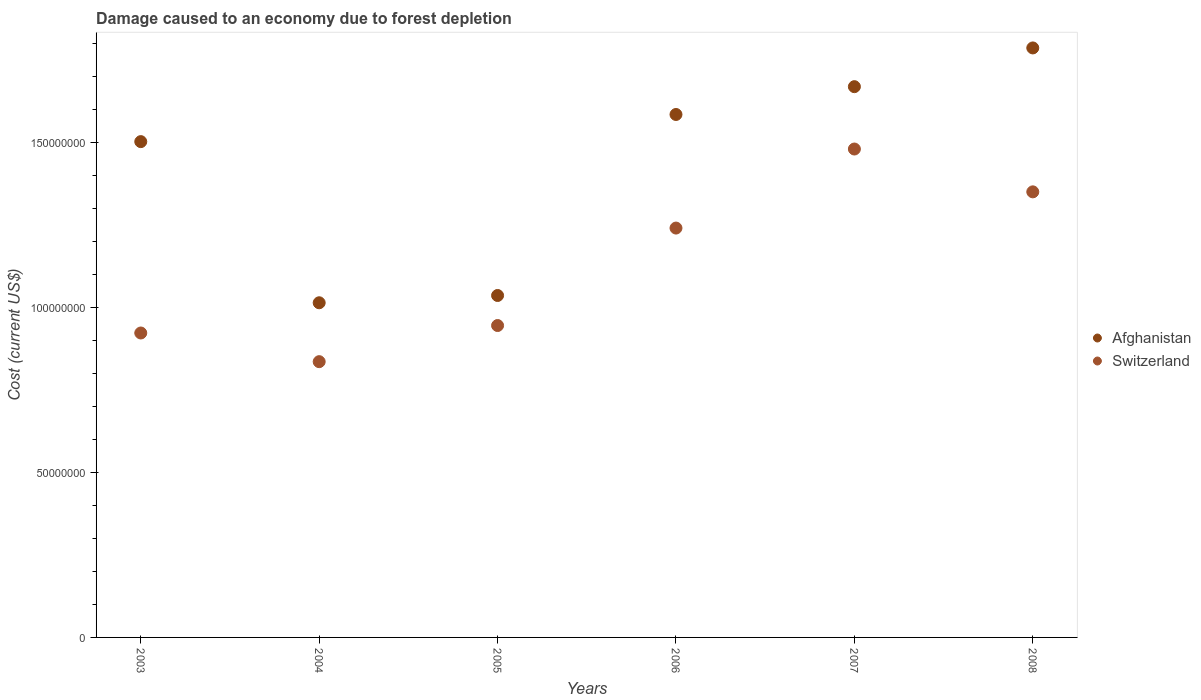Is the number of dotlines equal to the number of legend labels?
Your answer should be very brief. Yes. What is the cost of damage caused due to forest depletion in Afghanistan in 2005?
Your answer should be very brief. 1.04e+08. Across all years, what is the maximum cost of damage caused due to forest depletion in Switzerland?
Offer a very short reply. 1.48e+08. Across all years, what is the minimum cost of damage caused due to forest depletion in Afghanistan?
Your answer should be very brief. 1.01e+08. In which year was the cost of damage caused due to forest depletion in Afghanistan maximum?
Give a very brief answer. 2008. What is the total cost of damage caused due to forest depletion in Afghanistan in the graph?
Offer a very short reply. 8.59e+08. What is the difference between the cost of damage caused due to forest depletion in Switzerland in 2004 and that in 2005?
Provide a succinct answer. -1.09e+07. What is the difference between the cost of damage caused due to forest depletion in Switzerland in 2005 and the cost of damage caused due to forest depletion in Afghanistan in 2008?
Provide a short and direct response. -8.41e+07. What is the average cost of damage caused due to forest depletion in Afghanistan per year?
Provide a short and direct response. 1.43e+08. In the year 2006, what is the difference between the cost of damage caused due to forest depletion in Afghanistan and cost of damage caused due to forest depletion in Switzerland?
Offer a very short reply. 3.44e+07. In how many years, is the cost of damage caused due to forest depletion in Switzerland greater than 10000000 US$?
Offer a terse response. 6. What is the ratio of the cost of damage caused due to forest depletion in Afghanistan in 2006 to that in 2007?
Make the answer very short. 0.95. What is the difference between the highest and the second highest cost of damage caused due to forest depletion in Afghanistan?
Offer a very short reply. 1.17e+07. What is the difference between the highest and the lowest cost of damage caused due to forest depletion in Afghanistan?
Your response must be concise. 7.72e+07. Is the sum of the cost of damage caused due to forest depletion in Afghanistan in 2003 and 2006 greater than the maximum cost of damage caused due to forest depletion in Switzerland across all years?
Your answer should be very brief. Yes. Does the cost of damage caused due to forest depletion in Afghanistan monotonically increase over the years?
Your answer should be very brief. No. Is the cost of damage caused due to forest depletion in Afghanistan strictly greater than the cost of damage caused due to forest depletion in Switzerland over the years?
Offer a terse response. Yes. How many years are there in the graph?
Give a very brief answer. 6. What is the difference between two consecutive major ticks on the Y-axis?
Offer a terse response. 5.00e+07. Are the values on the major ticks of Y-axis written in scientific E-notation?
Your answer should be very brief. No. Does the graph contain grids?
Offer a very short reply. No. How are the legend labels stacked?
Keep it short and to the point. Vertical. What is the title of the graph?
Offer a very short reply. Damage caused to an economy due to forest depletion. What is the label or title of the Y-axis?
Provide a succinct answer. Cost (current US$). What is the Cost (current US$) in Afghanistan in 2003?
Offer a terse response. 1.50e+08. What is the Cost (current US$) of Switzerland in 2003?
Provide a succinct answer. 9.22e+07. What is the Cost (current US$) of Afghanistan in 2004?
Provide a succinct answer. 1.01e+08. What is the Cost (current US$) of Switzerland in 2004?
Your answer should be very brief. 8.35e+07. What is the Cost (current US$) in Afghanistan in 2005?
Your answer should be compact. 1.04e+08. What is the Cost (current US$) in Switzerland in 2005?
Keep it short and to the point. 9.45e+07. What is the Cost (current US$) in Afghanistan in 2006?
Give a very brief answer. 1.58e+08. What is the Cost (current US$) of Switzerland in 2006?
Offer a very short reply. 1.24e+08. What is the Cost (current US$) in Afghanistan in 2007?
Make the answer very short. 1.67e+08. What is the Cost (current US$) of Switzerland in 2007?
Offer a terse response. 1.48e+08. What is the Cost (current US$) of Afghanistan in 2008?
Your answer should be very brief. 1.79e+08. What is the Cost (current US$) in Switzerland in 2008?
Keep it short and to the point. 1.35e+08. Across all years, what is the maximum Cost (current US$) of Afghanistan?
Offer a terse response. 1.79e+08. Across all years, what is the maximum Cost (current US$) of Switzerland?
Your response must be concise. 1.48e+08. Across all years, what is the minimum Cost (current US$) in Afghanistan?
Provide a short and direct response. 1.01e+08. Across all years, what is the minimum Cost (current US$) in Switzerland?
Make the answer very short. 8.35e+07. What is the total Cost (current US$) of Afghanistan in the graph?
Your answer should be compact. 8.59e+08. What is the total Cost (current US$) in Switzerland in the graph?
Make the answer very short. 6.77e+08. What is the difference between the Cost (current US$) of Afghanistan in 2003 and that in 2004?
Your response must be concise. 4.88e+07. What is the difference between the Cost (current US$) of Switzerland in 2003 and that in 2004?
Offer a terse response. 8.68e+06. What is the difference between the Cost (current US$) in Afghanistan in 2003 and that in 2005?
Offer a very short reply. 4.66e+07. What is the difference between the Cost (current US$) of Switzerland in 2003 and that in 2005?
Make the answer very short. -2.26e+06. What is the difference between the Cost (current US$) of Afghanistan in 2003 and that in 2006?
Provide a succinct answer. -8.22e+06. What is the difference between the Cost (current US$) in Switzerland in 2003 and that in 2006?
Your answer should be compact. -3.18e+07. What is the difference between the Cost (current US$) of Afghanistan in 2003 and that in 2007?
Offer a terse response. -1.66e+07. What is the difference between the Cost (current US$) of Switzerland in 2003 and that in 2007?
Your answer should be very brief. -5.57e+07. What is the difference between the Cost (current US$) of Afghanistan in 2003 and that in 2008?
Offer a terse response. -2.84e+07. What is the difference between the Cost (current US$) in Switzerland in 2003 and that in 2008?
Offer a terse response. -4.28e+07. What is the difference between the Cost (current US$) in Afghanistan in 2004 and that in 2005?
Your answer should be very brief. -2.20e+06. What is the difference between the Cost (current US$) of Switzerland in 2004 and that in 2005?
Your answer should be compact. -1.09e+07. What is the difference between the Cost (current US$) in Afghanistan in 2004 and that in 2006?
Provide a short and direct response. -5.70e+07. What is the difference between the Cost (current US$) of Switzerland in 2004 and that in 2006?
Your answer should be very brief. -4.05e+07. What is the difference between the Cost (current US$) of Afghanistan in 2004 and that in 2007?
Give a very brief answer. -6.55e+07. What is the difference between the Cost (current US$) in Switzerland in 2004 and that in 2007?
Give a very brief answer. -6.44e+07. What is the difference between the Cost (current US$) of Afghanistan in 2004 and that in 2008?
Your answer should be very brief. -7.72e+07. What is the difference between the Cost (current US$) of Switzerland in 2004 and that in 2008?
Give a very brief answer. -5.14e+07. What is the difference between the Cost (current US$) in Afghanistan in 2005 and that in 2006?
Your response must be concise. -5.48e+07. What is the difference between the Cost (current US$) of Switzerland in 2005 and that in 2006?
Give a very brief answer. -2.95e+07. What is the difference between the Cost (current US$) of Afghanistan in 2005 and that in 2007?
Make the answer very short. -6.33e+07. What is the difference between the Cost (current US$) of Switzerland in 2005 and that in 2007?
Your answer should be compact. -5.35e+07. What is the difference between the Cost (current US$) of Afghanistan in 2005 and that in 2008?
Keep it short and to the point. -7.50e+07. What is the difference between the Cost (current US$) of Switzerland in 2005 and that in 2008?
Your answer should be compact. -4.05e+07. What is the difference between the Cost (current US$) in Afghanistan in 2006 and that in 2007?
Offer a very short reply. -8.43e+06. What is the difference between the Cost (current US$) of Switzerland in 2006 and that in 2007?
Your answer should be compact. -2.39e+07. What is the difference between the Cost (current US$) of Afghanistan in 2006 and that in 2008?
Keep it short and to the point. -2.02e+07. What is the difference between the Cost (current US$) in Switzerland in 2006 and that in 2008?
Your answer should be very brief. -1.10e+07. What is the difference between the Cost (current US$) of Afghanistan in 2007 and that in 2008?
Provide a short and direct response. -1.17e+07. What is the difference between the Cost (current US$) in Switzerland in 2007 and that in 2008?
Provide a short and direct response. 1.30e+07. What is the difference between the Cost (current US$) in Afghanistan in 2003 and the Cost (current US$) in Switzerland in 2004?
Your answer should be compact. 6.67e+07. What is the difference between the Cost (current US$) in Afghanistan in 2003 and the Cost (current US$) in Switzerland in 2005?
Provide a succinct answer. 5.57e+07. What is the difference between the Cost (current US$) of Afghanistan in 2003 and the Cost (current US$) of Switzerland in 2006?
Offer a very short reply. 2.62e+07. What is the difference between the Cost (current US$) of Afghanistan in 2003 and the Cost (current US$) of Switzerland in 2007?
Make the answer very short. 2.24e+06. What is the difference between the Cost (current US$) of Afghanistan in 2003 and the Cost (current US$) of Switzerland in 2008?
Offer a terse response. 1.52e+07. What is the difference between the Cost (current US$) of Afghanistan in 2004 and the Cost (current US$) of Switzerland in 2005?
Offer a terse response. 6.89e+06. What is the difference between the Cost (current US$) in Afghanistan in 2004 and the Cost (current US$) in Switzerland in 2006?
Provide a succinct answer. -2.26e+07. What is the difference between the Cost (current US$) of Afghanistan in 2004 and the Cost (current US$) of Switzerland in 2007?
Your answer should be very brief. -4.66e+07. What is the difference between the Cost (current US$) of Afghanistan in 2004 and the Cost (current US$) of Switzerland in 2008?
Your answer should be compact. -3.36e+07. What is the difference between the Cost (current US$) of Afghanistan in 2005 and the Cost (current US$) of Switzerland in 2006?
Your response must be concise. -2.04e+07. What is the difference between the Cost (current US$) of Afghanistan in 2005 and the Cost (current US$) of Switzerland in 2007?
Provide a short and direct response. -4.44e+07. What is the difference between the Cost (current US$) of Afghanistan in 2005 and the Cost (current US$) of Switzerland in 2008?
Your answer should be compact. -3.14e+07. What is the difference between the Cost (current US$) of Afghanistan in 2006 and the Cost (current US$) of Switzerland in 2007?
Ensure brevity in your answer.  1.05e+07. What is the difference between the Cost (current US$) in Afghanistan in 2006 and the Cost (current US$) in Switzerland in 2008?
Make the answer very short. 2.34e+07. What is the difference between the Cost (current US$) in Afghanistan in 2007 and the Cost (current US$) in Switzerland in 2008?
Ensure brevity in your answer.  3.19e+07. What is the average Cost (current US$) in Afghanistan per year?
Your answer should be very brief. 1.43e+08. What is the average Cost (current US$) of Switzerland per year?
Provide a succinct answer. 1.13e+08. In the year 2003, what is the difference between the Cost (current US$) in Afghanistan and Cost (current US$) in Switzerland?
Offer a very short reply. 5.80e+07. In the year 2004, what is the difference between the Cost (current US$) in Afghanistan and Cost (current US$) in Switzerland?
Your answer should be compact. 1.78e+07. In the year 2005, what is the difference between the Cost (current US$) of Afghanistan and Cost (current US$) of Switzerland?
Your response must be concise. 9.10e+06. In the year 2006, what is the difference between the Cost (current US$) in Afghanistan and Cost (current US$) in Switzerland?
Keep it short and to the point. 3.44e+07. In the year 2007, what is the difference between the Cost (current US$) in Afghanistan and Cost (current US$) in Switzerland?
Your answer should be very brief. 1.89e+07. In the year 2008, what is the difference between the Cost (current US$) in Afghanistan and Cost (current US$) in Switzerland?
Keep it short and to the point. 4.36e+07. What is the ratio of the Cost (current US$) in Afghanistan in 2003 to that in 2004?
Your answer should be compact. 1.48. What is the ratio of the Cost (current US$) of Switzerland in 2003 to that in 2004?
Offer a terse response. 1.1. What is the ratio of the Cost (current US$) of Afghanistan in 2003 to that in 2005?
Your response must be concise. 1.45. What is the ratio of the Cost (current US$) in Switzerland in 2003 to that in 2005?
Your answer should be very brief. 0.98. What is the ratio of the Cost (current US$) of Afghanistan in 2003 to that in 2006?
Make the answer very short. 0.95. What is the ratio of the Cost (current US$) of Switzerland in 2003 to that in 2006?
Ensure brevity in your answer.  0.74. What is the ratio of the Cost (current US$) of Afghanistan in 2003 to that in 2007?
Your answer should be very brief. 0.9. What is the ratio of the Cost (current US$) of Switzerland in 2003 to that in 2007?
Provide a succinct answer. 0.62. What is the ratio of the Cost (current US$) of Afghanistan in 2003 to that in 2008?
Ensure brevity in your answer.  0.84. What is the ratio of the Cost (current US$) in Switzerland in 2003 to that in 2008?
Your response must be concise. 0.68. What is the ratio of the Cost (current US$) of Afghanistan in 2004 to that in 2005?
Your answer should be compact. 0.98. What is the ratio of the Cost (current US$) of Switzerland in 2004 to that in 2005?
Your answer should be very brief. 0.88. What is the ratio of the Cost (current US$) in Afghanistan in 2004 to that in 2006?
Your answer should be very brief. 0.64. What is the ratio of the Cost (current US$) in Switzerland in 2004 to that in 2006?
Give a very brief answer. 0.67. What is the ratio of the Cost (current US$) in Afghanistan in 2004 to that in 2007?
Offer a very short reply. 0.61. What is the ratio of the Cost (current US$) of Switzerland in 2004 to that in 2007?
Provide a succinct answer. 0.56. What is the ratio of the Cost (current US$) in Afghanistan in 2004 to that in 2008?
Your response must be concise. 0.57. What is the ratio of the Cost (current US$) of Switzerland in 2004 to that in 2008?
Keep it short and to the point. 0.62. What is the ratio of the Cost (current US$) of Afghanistan in 2005 to that in 2006?
Keep it short and to the point. 0.65. What is the ratio of the Cost (current US$) in Switzerland in 2005 to that in 2006?
Make the answer very short. 0.76. What is the ratio of the Cost (current US$) in Afghanistan in 2005 to that in 2007?
Make the answer very short. 0.62. What is the ratio of the Cost (current US$) of Switzerland in 2005 to that in 2007?
Give a very brief answer. 0.64. What is the ratio of the Cost (current US$) in Afghanistan in 2005 to that in 2008?
Your response must be concise. 0.58. What is the ratio of the Cost (current US$) in Switzerland in 2005 to that in 2008?
Provide a short and direct response. 0.7. What is the ratio of the Cost (current US$) in Afghanistan in 2006 to that in 2007?
Your answer should be compact. 0.95. What is the ratio of the Cost (current US$) in Switzerland in 2006 to that in 2007?
Offer a terse response. 0.84. What is the ratio of the Cost (current US$) in Afghanistan in 2006 to that in 2008?
Give a very brief answer. 0.89. What is the ratio of the Cost (current US$) in Switzerland in 2006 to that in 2008?
Your answer should be very brief. 0.92. What is the ratio of the Cost (current US$) in Afghanistan in 2007 to that in 2008?
Your response must be concise. 0.93. What is the ratio of the Cost (current US$) in Switzerland in 2007 to that in 2008?
Your response must be concise. 1.1. What is the difference between the highest and the second highest Cost (current US$) of Afghanistan?
Offer a terse response. 1.17e+07. What is the difference between the highest and the second highest Cost (current US$) in Switzerland?
Ensure brevity in your answer.  1.30e+07. What is the difference between the highest and the lowest Cost (current US$) in Afghanistan?
Offer a very short reply. 7.72e+07. What is the difference between the highest and the lowest Cost (current US$) of Switzerland?
Provide a short and direct response. 6.44e+07. 